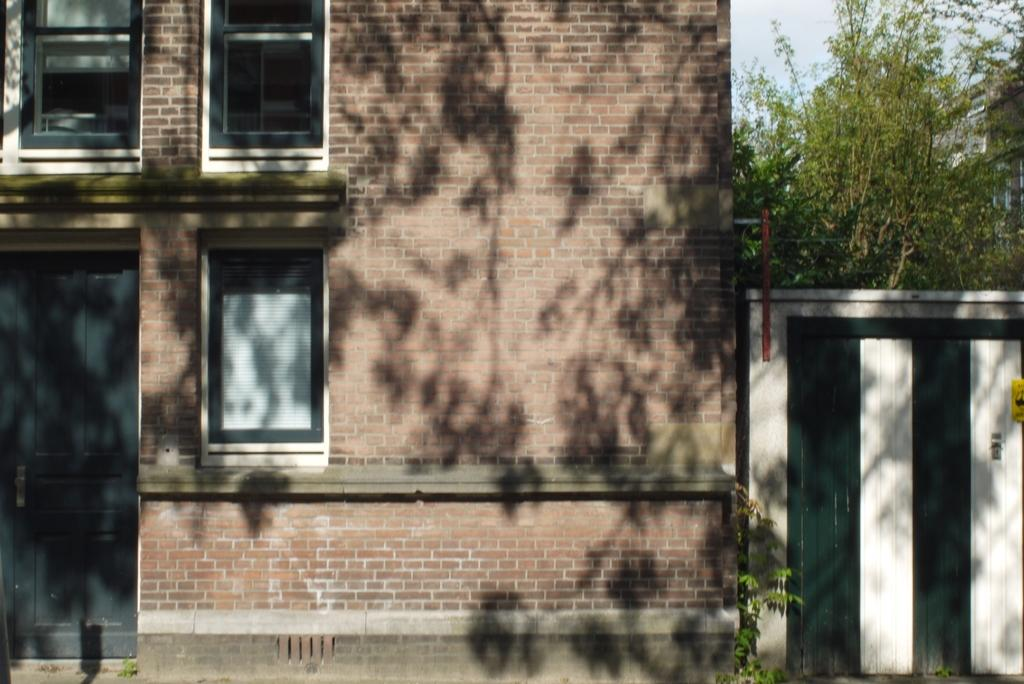What type of structures can be seen in the image? There are buildings in the image. What features do the buildings have? The buildings have windows. Is there any entrance visible in the image? Yes, there is a door visible in the image. What type of barrier is present in the image? There is fencing in the image. What type of vegetation can be seen in the image? There are plants and trees in the image. What part of the natural environment is visible in the image? The sky is visible in the image. What type of oatmeal is being served to the visitor in the image? There is no oatmeal or visitor present in the image. What type of pancake is being flipped by the chef in the image? There is no chef or pancake present in the image. 